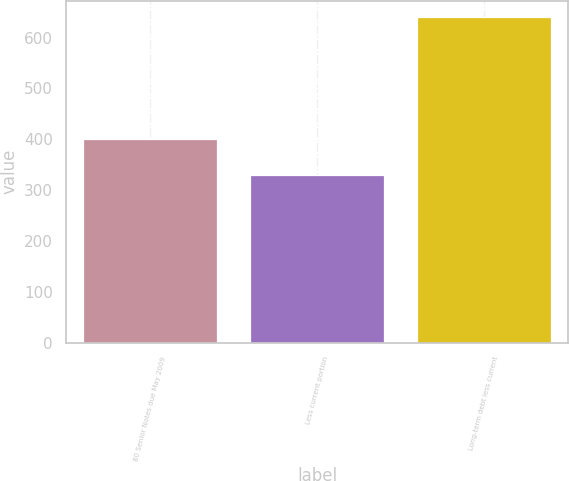<chart> <loc_0><loc_0><loc_500><loc_500><bar_chart><fcel>80 Senior Notes due May 2009<fcel>Less current portion<fcel>Long-term debt less current<nl><fcel>400<fcel>330<fcel>640<nl></chart> 